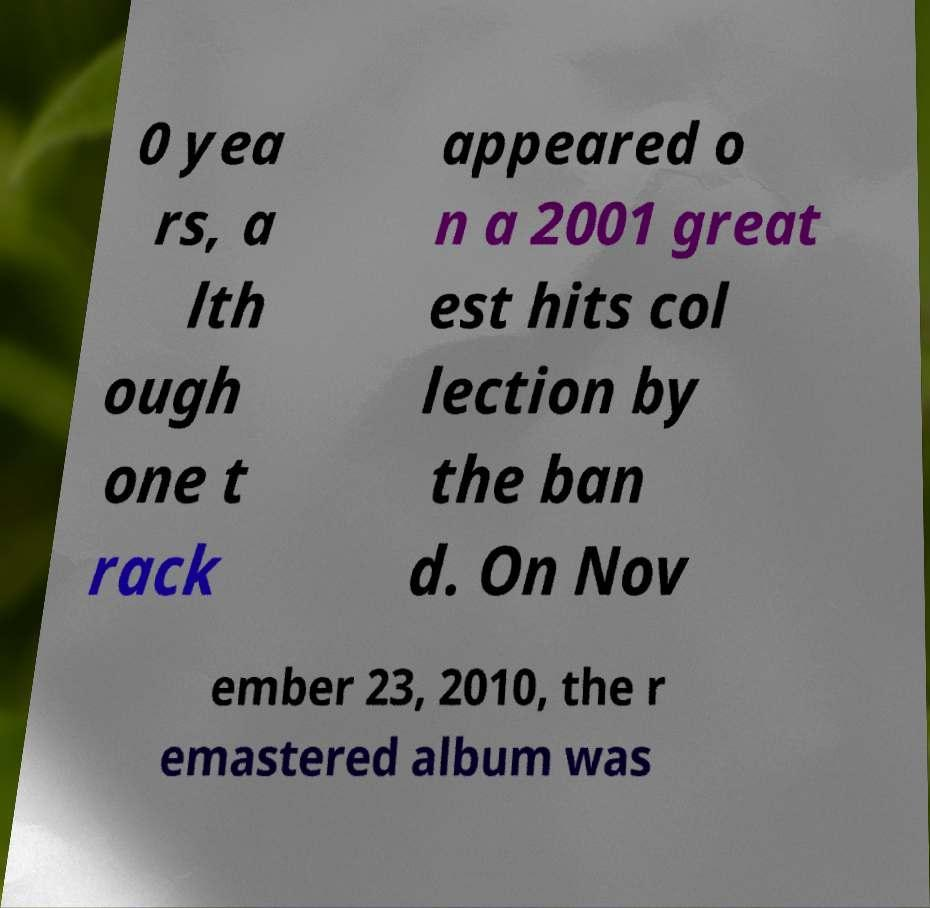For documentation purposes, I need the text within this image transcribed. Could you provide that? 0 yea rs, a lth ough one t rack appeared o n a 2001 great est hits col lection by the ban d. On Nov ember 23, 2010, the r emastered album was 